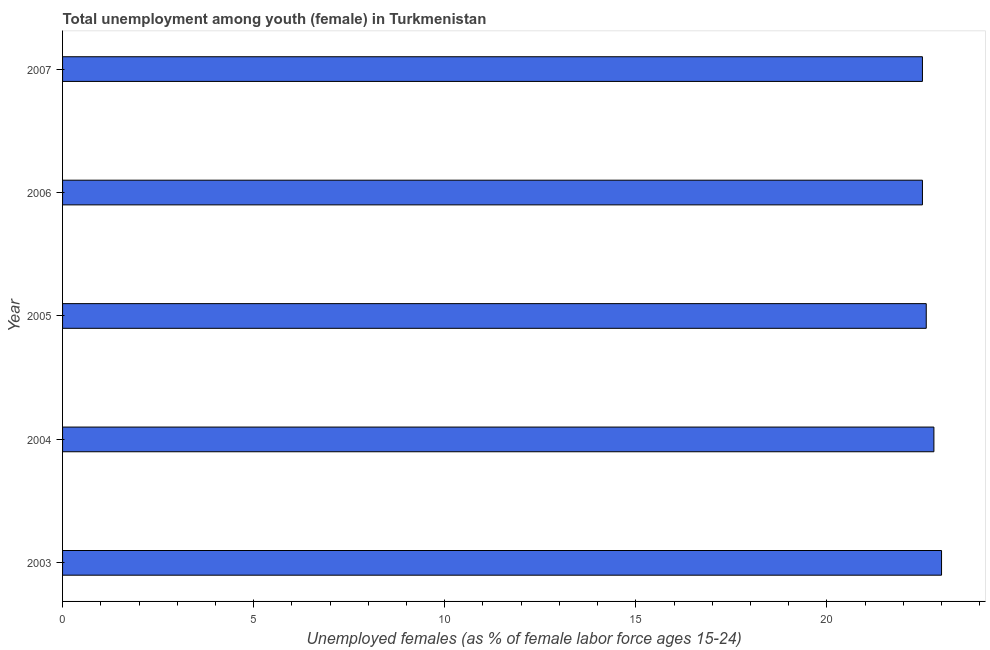Does the graph contain grids?
Keep it short and to the point. No. What is the title of the graph?
Keep it short and to the point. Total unemployment among youth (female) in Turkmenistan. What is the label or title of the X-axis?
Your answer should be compact. Unemployed females (as % of female labor force ages 15-24). What is the label or title of the Y-axis?
Give a very brief answer. Year. What is the unemployed female youth population in 2004?
Your answer should be compact. 22.8. In which year was the unemployed female youth population minimum?
Your response must be concise. 2006. What is the sum of the unemployed female youth population?
Provide a short and direct response. 113.4. What is the average unemployed female youth population per year?
Your answer should be very brief. 22.68. What is the median unemployed female youth population?
Make the answer very short. 22.6. In how many years, is the unemployed female youth population greater than 1 %?
Provide a succinct answer. 5. Do a majority of the years between 2003 and 2007 (inclusive) have unemployed female youth population greater than 18 %?
Give a very brief answer. Yes. What is the difference between the highest and the second highest unemployed female youth population?
Your response must be concise. 0.2. Is the sum of the unemployed female youth population in 2003 and 2007 greater than the maximum unemployed female youth population across all years?
Make the answer very short. Yes. In how many years, is the unemployed female youth population greater than the average unemployed female youth population taken over all years?
Provide a succinct answer. 2. What is the difference between two consecutive major ticks on the X-axis?
Provide a short and direct response. 5. What is the Unemployed females (as % of female labor force ages 15-24) of 2003?
Offer a terse response. 23. What is the Unemployed females (as % of female labor force ages 15-24) of 2004?
Your answer should be very brief. 22.8. What is the Unemployed females (as % of female labor force ages 15-24) in 2005?
Keep it short and to the point. 22.6. What is the Unemployed females (as % of female labor force ages 15-24) in 2006?
Provide a succinct answer. 22.5. What is the Unemployed females (as % of female labor force ages 15-24) in 2007?
Offer a terse response. 22.5. What is the difference between the Unemployed females (as % of female labor force ages 15-24) in 2003 and 2004?
Keep it short and to the point. 0.2. What is the difference between the Unemployed females (as % of female labor force ages 15-24) in 2004 and 2005?
Offer a very short reply. 0.2. What is the difference between the Unemployed females (as % of female labor force ages 15-24) in 2004 and 2007?
Give a very brief answer. 0.3. What is the difference between the Unemployed females (as % of female labor force ages 15-24) in 2005 and 2006?
Make the answer very short. 0.1. What is the difference between the Unemployed females (as % of female labor force ages 15-24) in 2005 and 2007?
Ensure brevity in your answer.  0.1. What is the ratio of the Unemployed females (as % of female labor force ages 15-24) in 2003 to that in 2004?
Provide a short and direct response. 1.01. What is the ratio of the Unemployed females (as % of female labor force ages 15-24) in 2003 to that in 2005?
Give a very brief answer. 1.02. What is the ratio of the Unemployed females (as % of female labor force ages 15-24) in 2003 to that in 2006?
Provide a short and direct response. 1.02. What is the ratio of the Unemployed females (as % of female labor force ages 15-24) in 2004 to that in 2006?
Provide a succinct answer. 1.01. What is the ratio of the Unemployed females (as % of female labor force ages 15-24) in 2005 to that in 2006?
Keep it short and to the point. 1. What is the ratio of the Unemployed females (as % of female labor force ages 15-24) in 2006 to that in 2007?
Give a very brief answer. 1. 